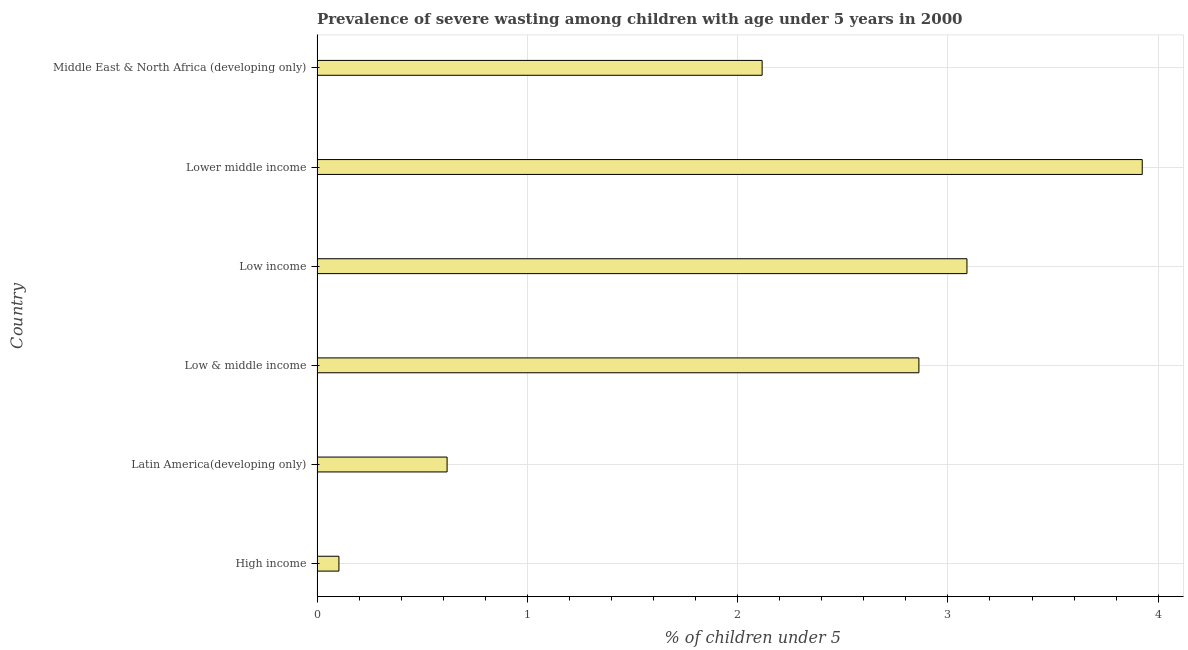Does the graph contain any zero values?
Keep it short and to the point. No. Does the graph contain grids?
Make the answer very short. Yes. What is the title of the graph?
Your answer should be very brief. Prevalence of severe wasting among children with age under 5 years in 2000. What is the label or title of the X-axis?
Provide a succinct answer.  % of children under 5. What is the prevalence of severe wasting in Middle East & North Africa (developing only)?
Your response must be concise. 2.12. Across all countries, what is the maximum prevalence of severe wasting?
Your answer should be very brief. 3.92. Across all countries, what is the minimum prevalence of severe wasting?
Provide a succinct answer. 0.1. In which country was the prevalence of severe wasting maximum?
Keep it short and to the point. Lower middle income. What is the sum of the prevalence of severe wasting?
Provide a succinct answer. 12.72. What is the difference between the prevalence of severe wasting in Latin America(developing only) and Low income?
Your response must be concise. -2.47. What is the average prevalence of severe wasting per country?
Make the answer very short. 2.12. What is the median prevalence of severe wasting?
Your response must be concise. 2.49. What is the ratio of the prevalence of severe wasting in Lower middle income to that in Middle East & North Africa (developing only)?
Ensure brevity in your answer.  1.85. What is the difference between the highest and the second highest prevalence of severe wasting?
Your answer should be compact. 0.83. Is the sum of the prevalence of severe wasting in Lower middle income and Middle East & North Africa (developing only) greater than the maximum prevalence of severe wasting across all countries?
Offer a very short reply. Yes. What is the difference between the highest and the lowest prevalence of severe wasting?
Provide a short and direct response. 3.82. Are all the bars in the graph horizontal?
Make the answer very short. Yes. What is the  % of children under 5 in High income?
Your answer should be very brief. 0.1. What is the  % of children under 5 of Latin America(developing only)?
Your answer should be very brief. 0.62. What is the  % of children under 5 of Low & middle income?
Give a very brief answer. 2.86. What is the  % of children under 5 in Low income?
Your response must be concise. 3.09. What is the  % of children under 5 of Lower middle income?
Make the answer very short. 3.92. What is the  % of children under 5 in Middle East & North Africa (developing only)?
Offer a very short reply. 2.12. What is the difference between the  % of children under 5 in High income and Latin America(developing only)?
Make the answer very short. -0.51. What is the difference between the  % of children under 5 in High income and Low & middle income?
Provide a succinct answer. -2.76. What is the difference between the  % of children under 5 in High income and Low income?
Your answer should be very brief. -2.99. What is the difference between the  % of children under 5 in High income and Lower middle income?
Provide a short and direct response. -3.82. What is the difference between the  % of children under 5 in High income and Middle East & North Africa (developing only)?
Keep it short and to the point. -2.01. What is the difference between the  % of children under 5 in Latin America(developing only) and Low & middle income?
Offer a terse response. -2.24. What is the difference between the  % of children under 5 in Latin America(developing only) and Low income?
Your answer should be very brief. -2.47. What is the difference between the  % of children under 5 in Latin America(developing only) and Lower middle income?
Your answer should be very brief. -3.31. What is the difference between the  % of children under 5 in Latin America(developing only) and Middle East & North Africa (developing only)?
Your answer should be compact. -1.5. What is the difference between the  % of children under 5 in Low & middle income and Low income?
Ensure brevity in your answer.  -0.23. What is the difference between the  % of children under 5 in Low & middle income and Lower middle income?
Your answer should be very brief. -1.06. What is the difference between the  % of children under 5 in Low & middle income and Middle East & North Africa (developing only)?
Offer a very short reply. 0.75. What is the difference between the  % of children under 5 in Low income and Lower middle income?
Provide a succinct answer. -0.83. What is the difference between the  % of children under 5 in Low income and Middle East & North Africa (developing only)?
Your answer should be very brief. 0.97. What is the difference between the  % of children under 5 in Lower middle income and Middle East & North Africa (developing only)?
Provide a short and direct response. 1.81. What is the ratio of the  % of children under 5 in High income to that in Latin America(developing only)?
Your answer should be compact. 0.17. What is the ratio of the  % of children under 5 in High income to that in Low & middle income?
Provide a short and direct response. 0.04. What is the ratio of the  % of children under 5 in High income to that in Low income?
Provide a short and direct response. 0.03. What is the ratio of the  % of children under 5 in High income to that in Lower middle income?
Offer a very short reply. 0.03. What is the ratio of the  % of children under 5 in High income to that in Middle East & North Africa (developing only)?
Make the answer very short. 0.05. What is the ratio of the  % of children under 5 in Latin America(developing only) to that in Low & middle income?
Offer a very short reply. 0.22. What is the ratio of the  % of children under 5 in Latin America(developing only) to that in Low income?
Your answer should be compact. 0.2. What is the ratio of the  % of children under 5 in Latin America(developing only) to that in Lower middle income?
Ensure brevity in your answer.  0.16. What is the ratio of the  % of children under 5 in Latin America(developing only) to that in Middle East & North Africa (developing only)?
Your response must be concise. 0.29. What is the ratio of the  % of children under 5 in Low & middle income to that in Low income?
Your answer should be very brief. 0.93. What is the ratio of the  % of children under 5 in Low & middle income to that in Lower middle income?
Make the answer very short. 0.73. What is the ratio of the  % of children under 5 in Low & middle income to that in Middle East & North Africa (developing only)?
Your response must be concise. 1.35. What is the ratio of the  % of children under 5 in Low income to that in Lower middle income?
Keep it short and to the point. 0.79. What is the ratio of the  % of children under 5 in Low income to that in Middle East & North Africa (developing only)?
Offer a terse response. 1.46. What is the ratio of the  % of children under 5 in Lower middle income to that in Middle East & North Africa (developing only)?
Your response must be concise. 1.85. 